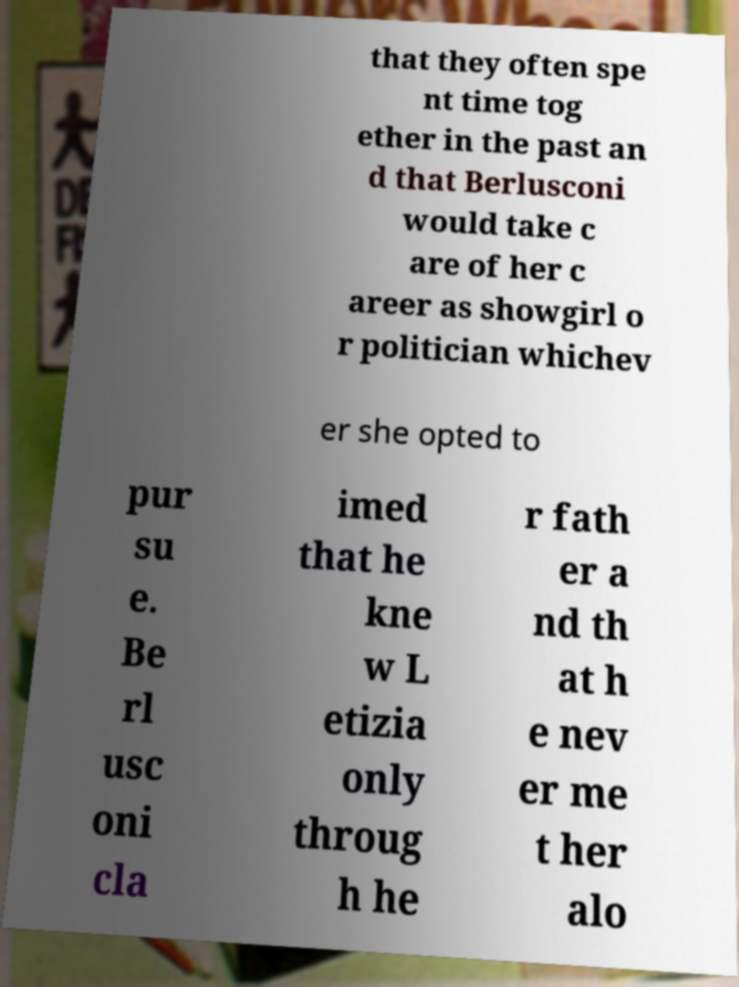Can you read and provide the text displayed in the image?This photo seems to have some interesting text. Can you extract and type it out for me? that they often spe nt time tog ether in the past an d that Berlusconi would take c are of her c areer as showgirl o r politician whichev er she opted to pur su e. Be rl usc oni cla imed that he kne w L etizia only throug h he r fath er a nd th at h e nev er me t her alo 